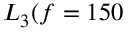<formula> <loc_0><loc_0><loc_500><loc_500>{ L } _ { 3 } ( f = 1 5 0</formula> 